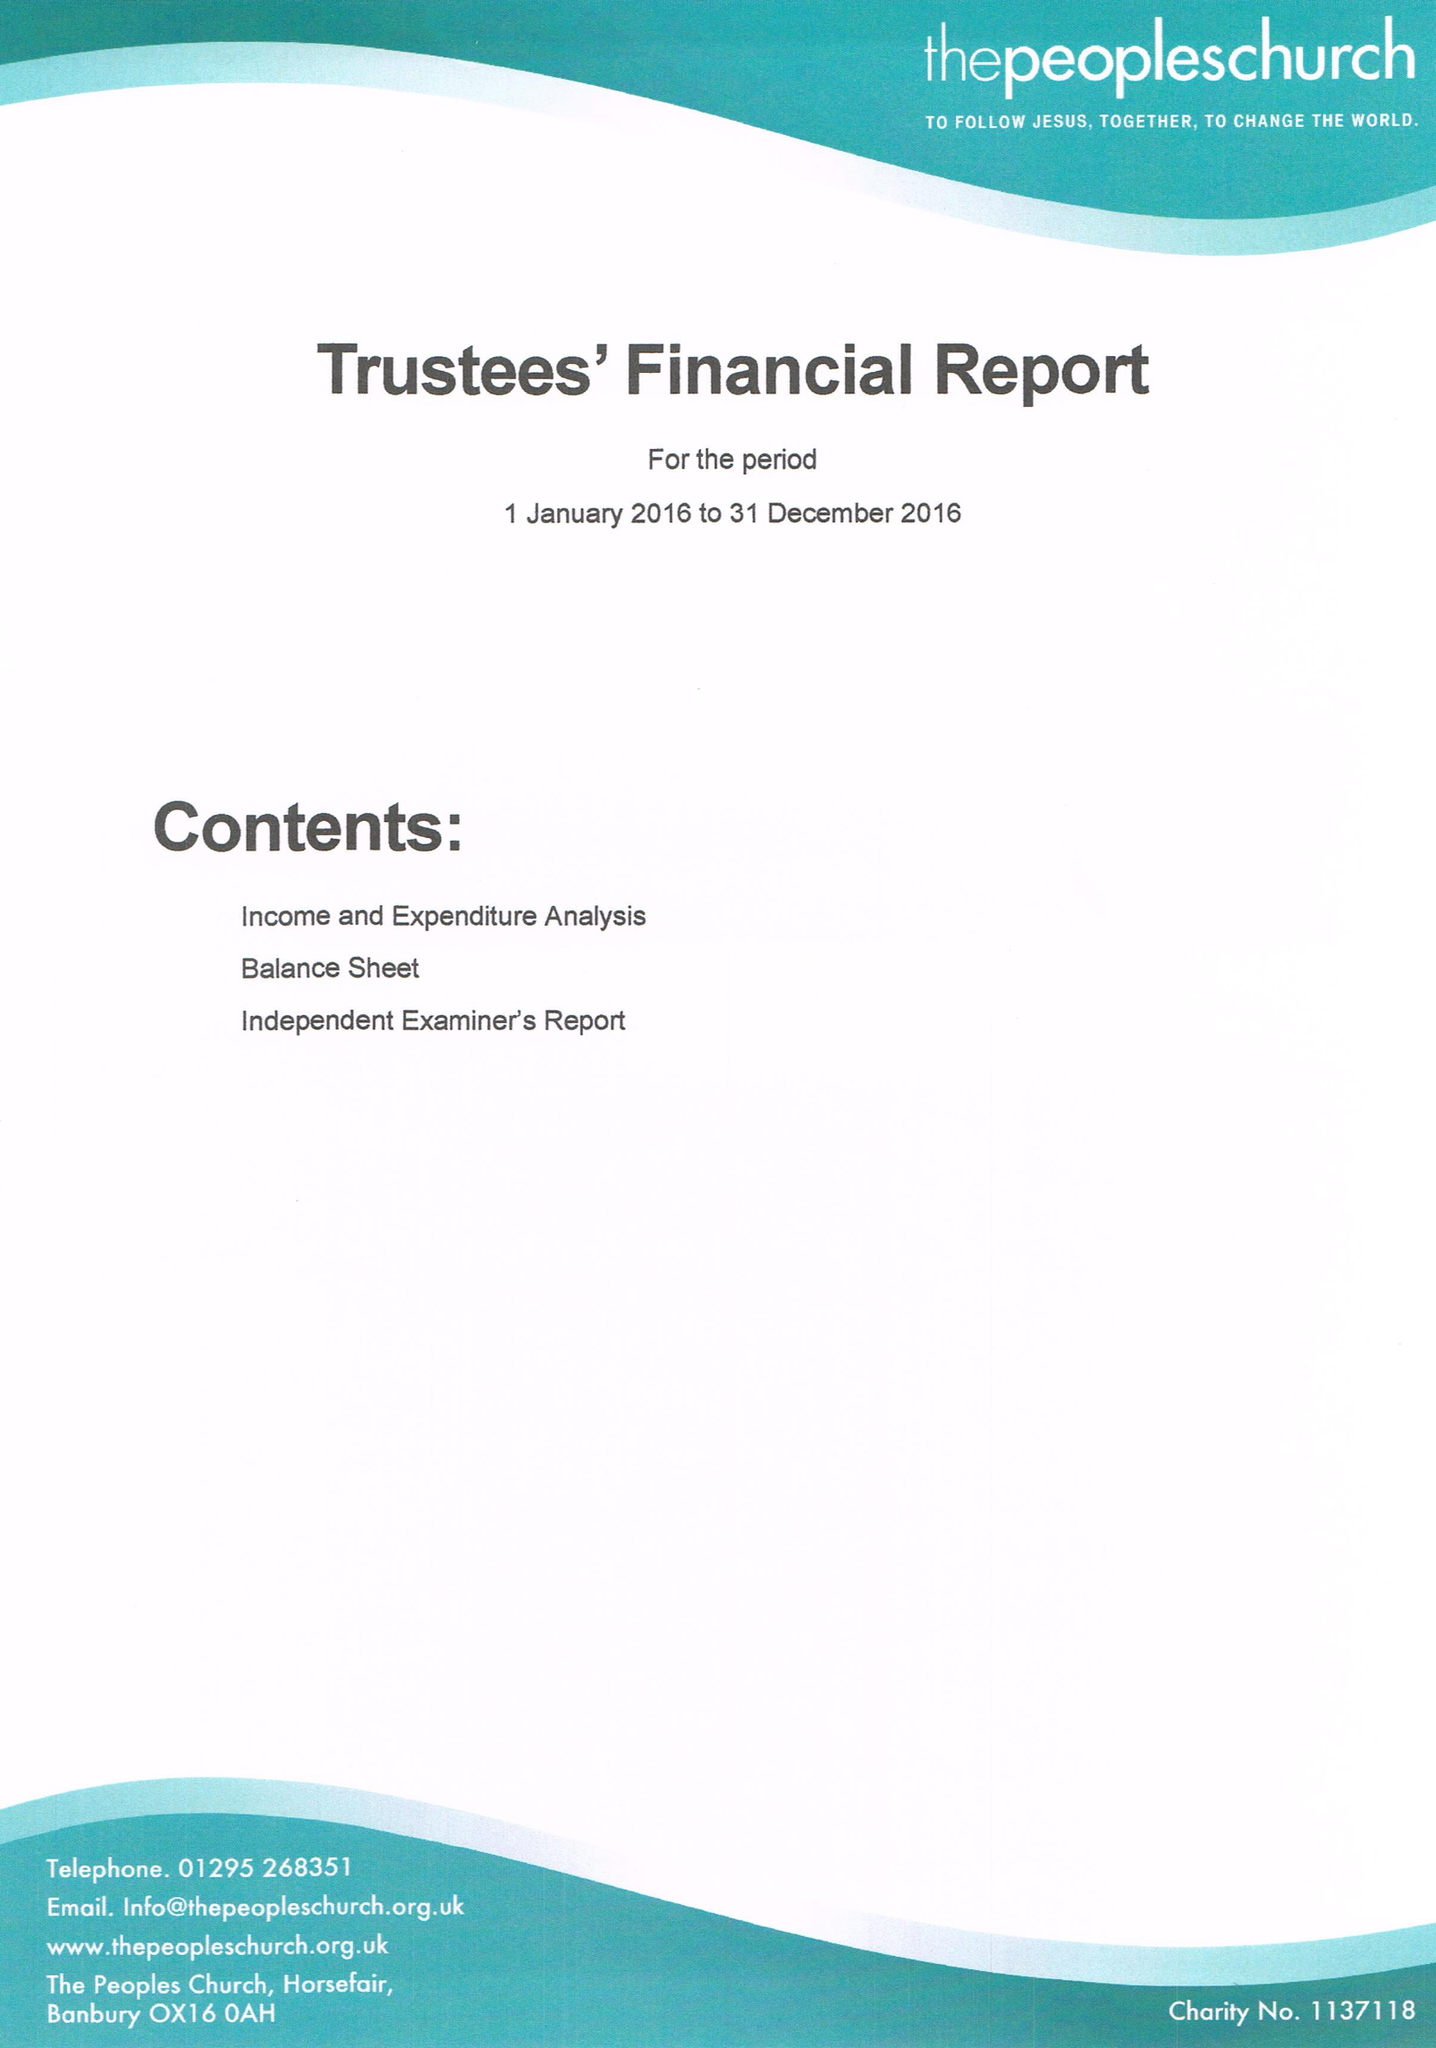What is the value for the income_annually_in_british_pounds?
Answer the question using a single word or phrase. 158091.81 